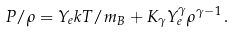Convert formula to latex. <formula><loc_0><loc_0><loc_500><loc_500>P / \rho = Y _ { e } k T / m _ { B } + K _ { \gamma } Y _ { e } ^ { \gamma } \rho ^ { \gamma - 1 } \, .</formula> 